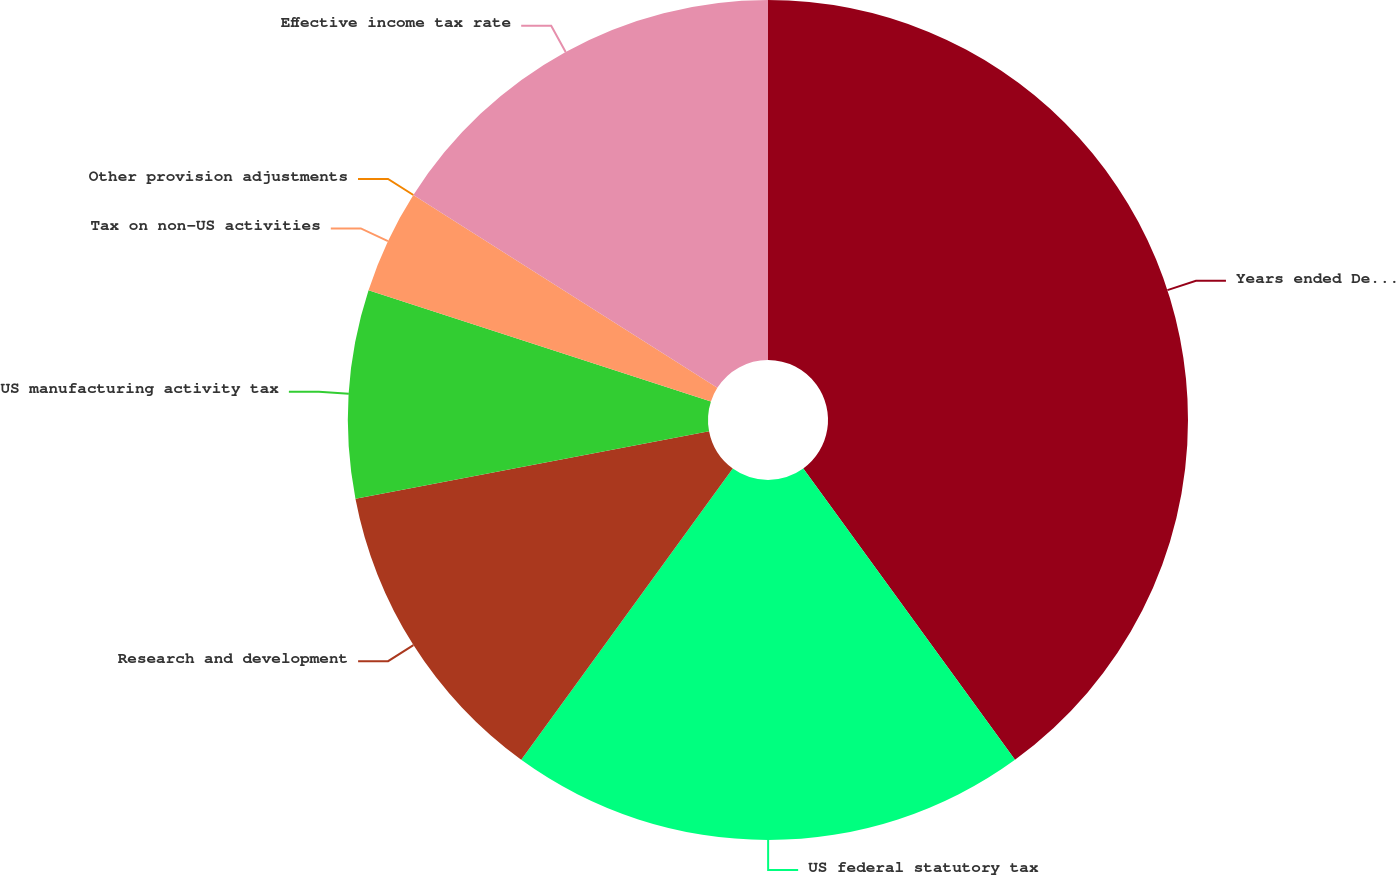Convert chart. <chart><loc_0><loc_0><loc_500><loc_500><pie_chart><fcel>Years ended December 31<fcel>US federal statutory tax<fcel>Research and development<fcel>US manufacturing activity tax<fcel>Tax on non-US activities<fcel>Other provision adjustments<fcel>Effective income tax rate<nl><fcel>39.99%<fcel>20.0%<fcel>12.0%<fcel>8.0%<fcel>4.0%<fcel>0.0%<fcel>16.0%<nl></chart> 